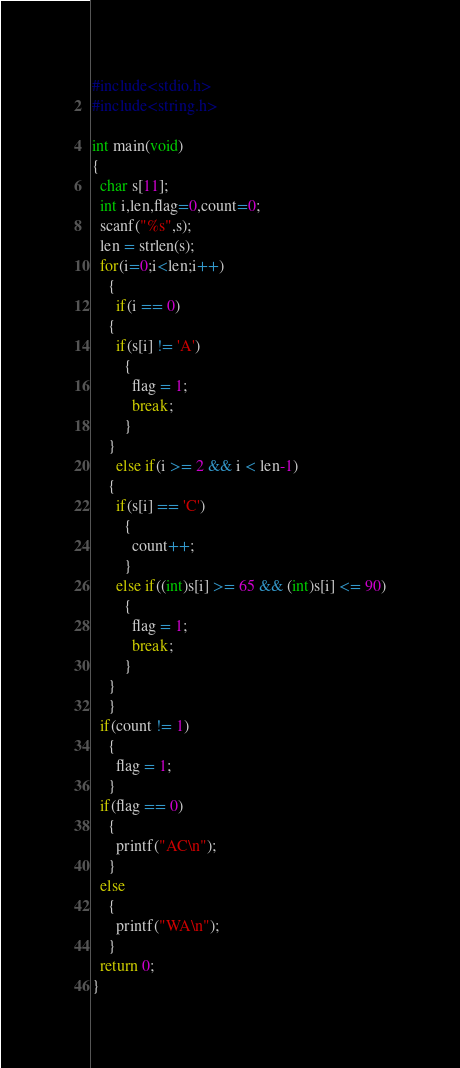<code> <loc_0><loc_0><loc_500><loc_500><_C_>#include<stdio.h>
#include<string.h>

int main(void)
{
  char s[11];
  int i,len,flag=0,count=0;
  scanf("%s",s);
  len = strlen(s);
  for(i=0;i<len;i++)
    {
      if(i == 0)
	{
	  if(s[i] != 'A')
	    {
	      flag = 1;
	      break;
	    }
	}
      else if(i >= 2 && i < len-1)
	{
	  if(s[i] == 'C')
	    {
	      count++;
	    }
	  else if((int)s[i] >= 65 && (int)s[i] <= 90)
	    {
	      flag = 1;
	      break;
	    }
	}
    }
  if(count != 1)
    {
      flag = 1;
    }
  if(flag == 0)
    {
      printf("AC\n");
    }
  else
    {
      printf("WA\n");
    }
  return 0;
}
</code> 